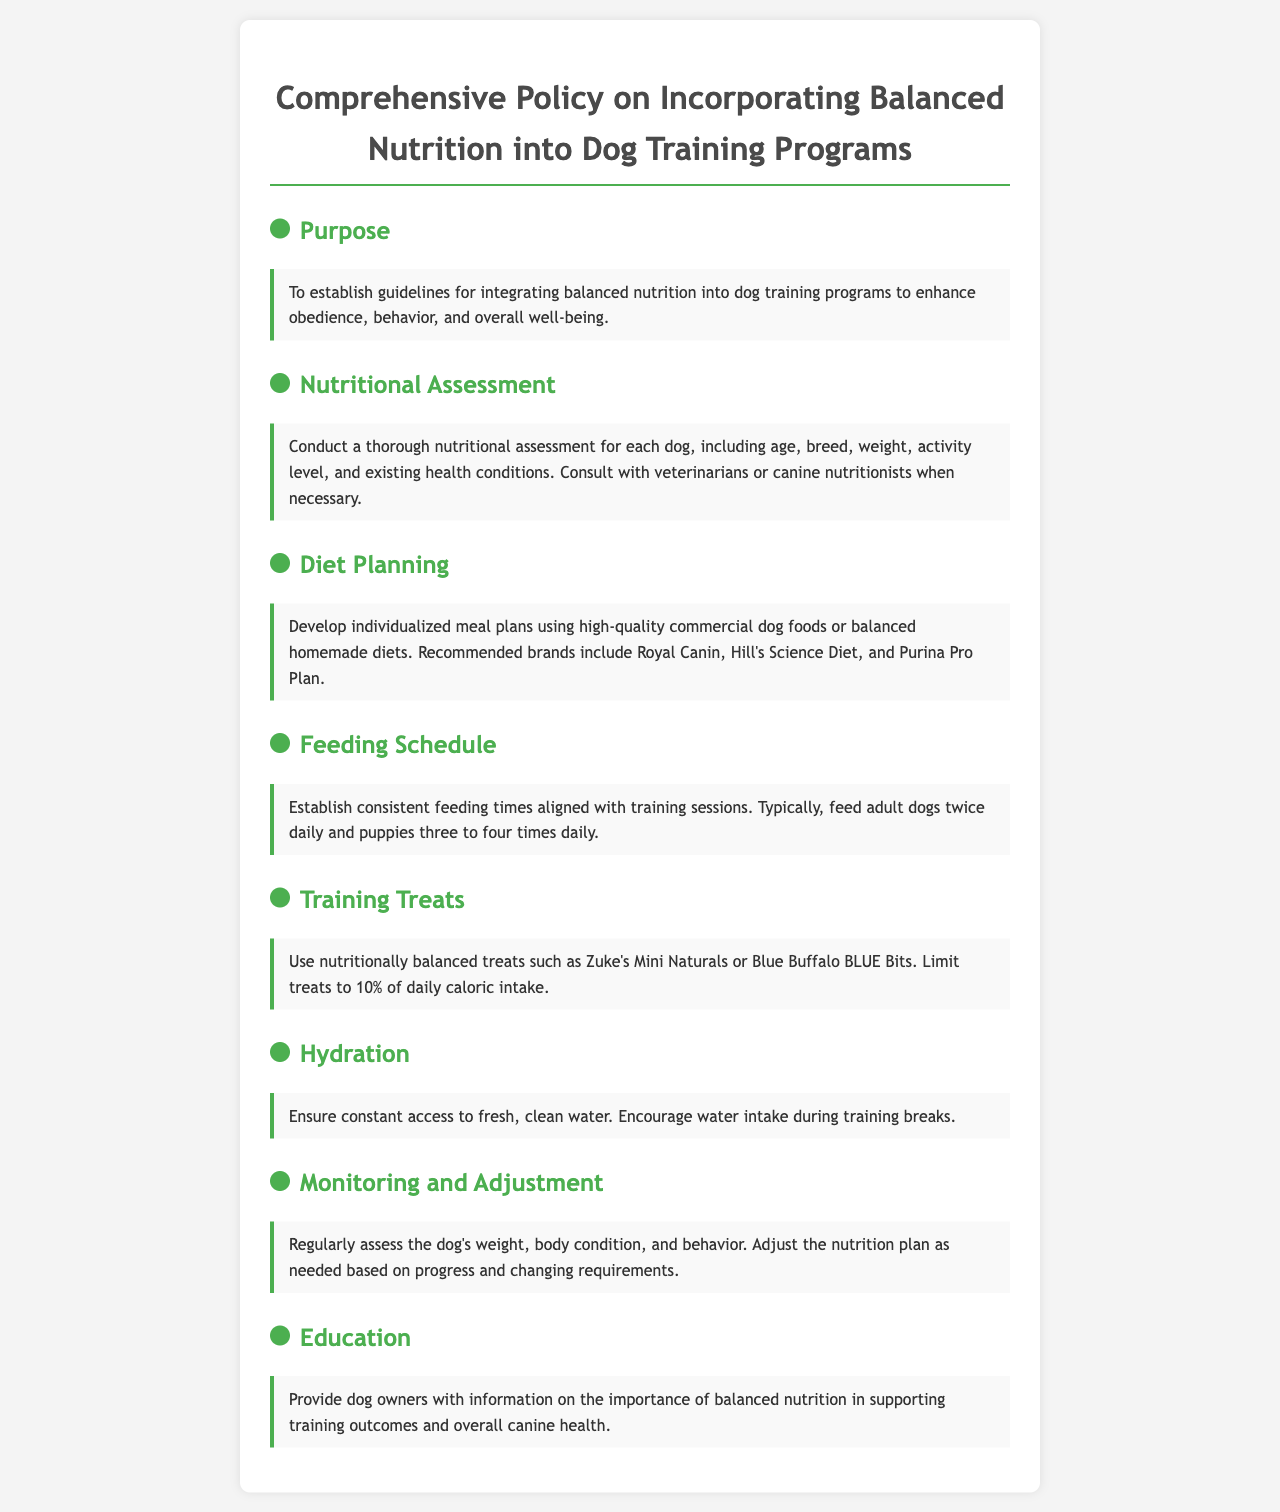What is the purpose of the policy? The purpose is to establish guidelines for integrating balanced nutrition into dog training programs to enhance obedience, behavior, and overall well-being.
Answer: To enhance obedience, behavior, and overall well-being What is included in the nutritional assessment? The nutritional assessment includes age, breed, weight, activity level, and existing health conditions.
Answer: Age, breed, weight, activity level, health conditions What are the recommended brands for diet planning? The document mentions Royal Canin, Hill's Science Diet, and Purina Pro Plan.
Answer: Royal Canin, Hill's Science Diet, Purina Pro Plan How often should adult dogs be fed according to the policy? The policy states that adult dogs should be fed twice daily.
Answer: Twice daily What percentage of daily caloric intake should treats be limited to? The document specifies that treats should be limited to 10% of daily caloric intake.
Answer: 10% What should be ensured regarding hydration? The policy emphasizes ensuring constant access to fresh, clean water.
Answer: Constant access to fresh, clean water How often should the dog's weight and body condition be assessed? The document suggests regular assessments of the dog's weight and body condition.
Answer: Regularly What is one educational topic provided to dog owners? Dog owners are educated on the importance of balanced nutrition in supporting training outcomes.
Answer: Importance of balanced nutrition 